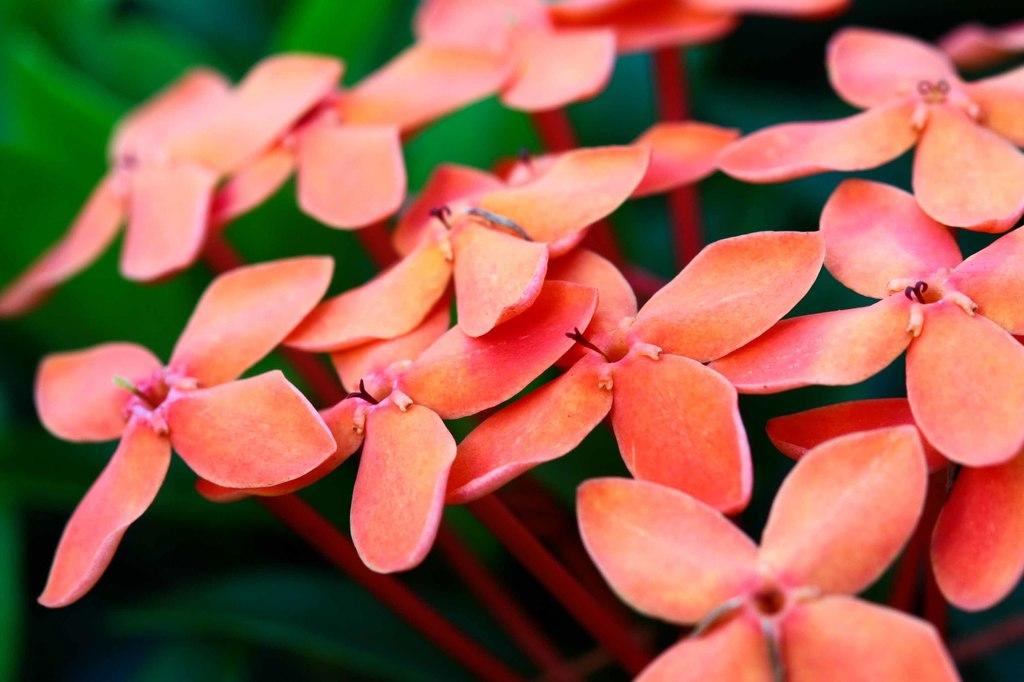What type of objects can be seen in the image? There are flowers in the image. Can you describe the color of the flowers? The flowers are in peach color. Is there an umbrella present in the image? No, there is no umbrella present in the image. Does the image provide evidence of the existence of extraterrestrial life? No, the image only shows flowers and does not provide any information about extraterrestrial life. 